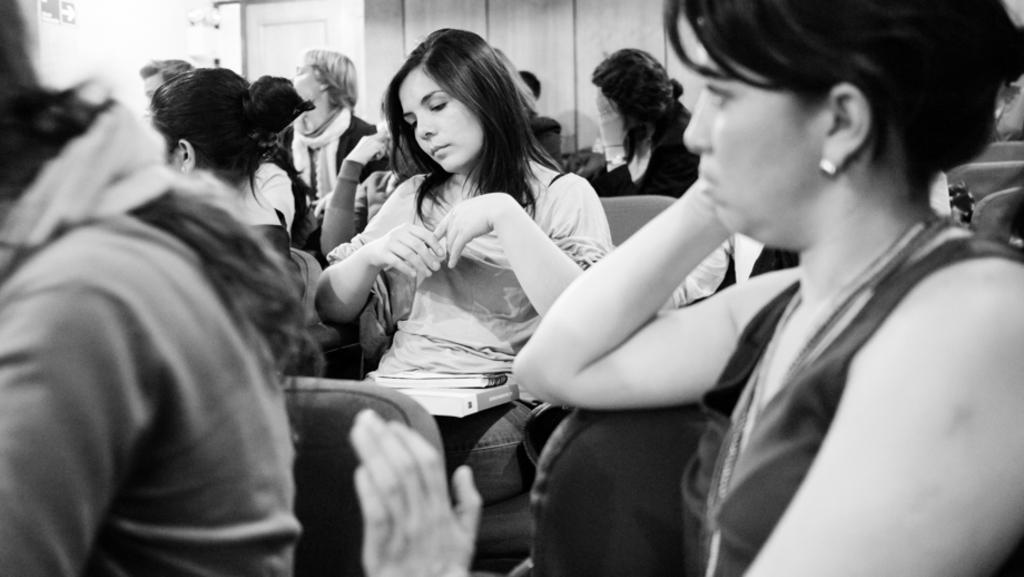How many people are in the image? There is a group of people in the image. What are the people doing in the image? The people are sitting on chairs. What can be seen in the background of the image? There is a wall in the background of the image. How many cows are present in the image? There are no cows present in the image; it features a group of people sitting on chairs with a wall in the background. What type of zipper can be seen on the people's clothing in the image? There is no specific zipper mentioned or visible in the image; it simply shows a group of people sitting on chairs with a wall in the background. 